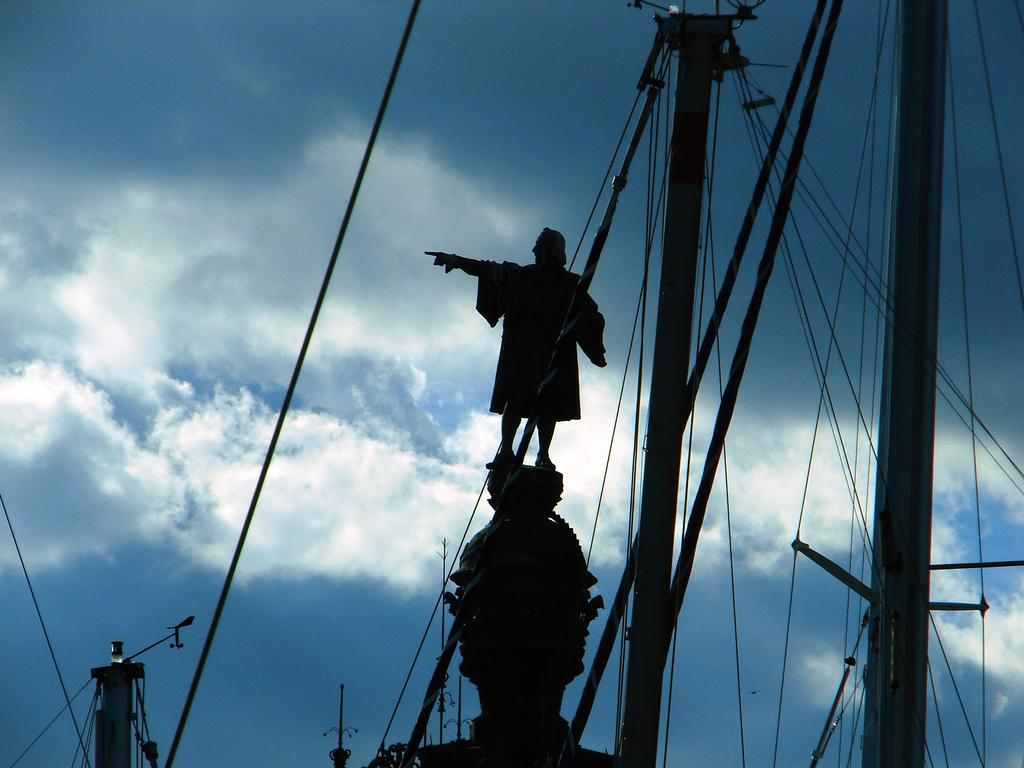What is the main subject in the middle of the image? There is a man statue in the middle of the image. What can be seen at the front bottom side of the image? There are many poles and cables in the front bottom side of the image. What is visible in the background of the image? The sky is visible in the image. What can be observed in the sky? Clouds are present in the sky. What type of jar is being used to collect rainwater in the image? There is no jar present in the image, nor is there any indication of rainwater collection. 